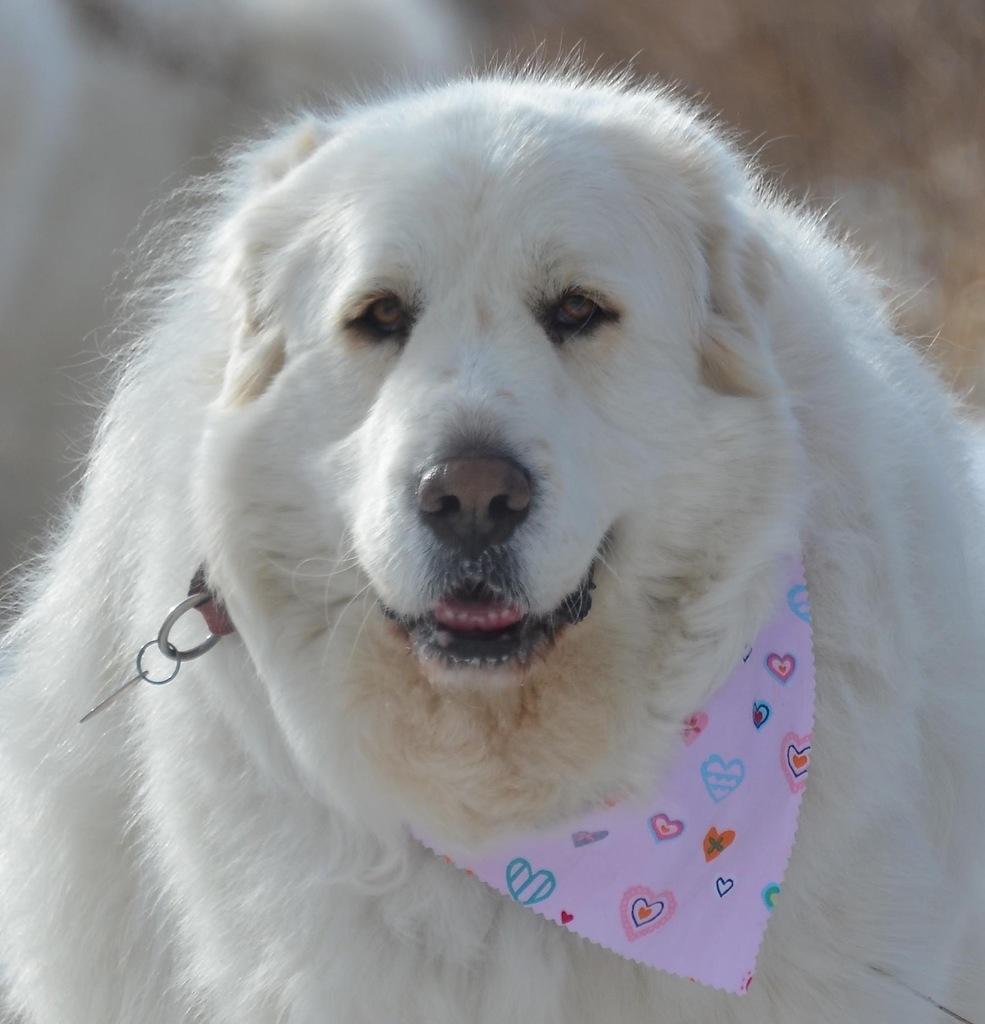How would you summarize this image in a sentence or two? In the center of the image we can see an animal. 